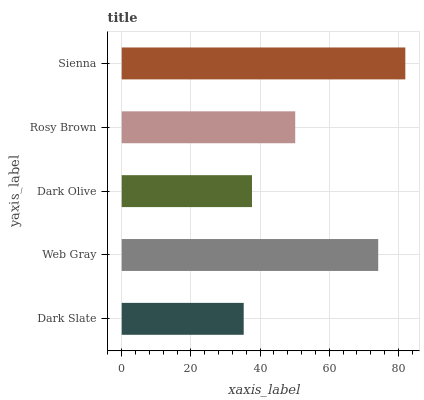Is Dark Slate the minimum?
Answer yes or no. Yes. Is Sienna the maximum?
Answer yes or no. Yes. Is Web Gray the minimum?
Answer yes or no. No. Is Web Gray the maximum?
Answer yes or no. No. Is Web Gray greater than Dark Slate?
Answer yes or no. Yes. Is Dark Slate less than Web Gray?
Answer yes or no. Yes. Is Dark Slate greater than Web Gray?
Answer yes or no. No. Is Web Gray less than Dark Slate?
Answer yes or no. No. Is Rosy Brown the high median?
Answer yes or no. Yes. Is Rosy Brown the low median?
Answer yes or no. Yes. Is Dark Olive the high median?
Answer yes or no. No. Is Dark Olive the low median?
Answer yes or no. No. 